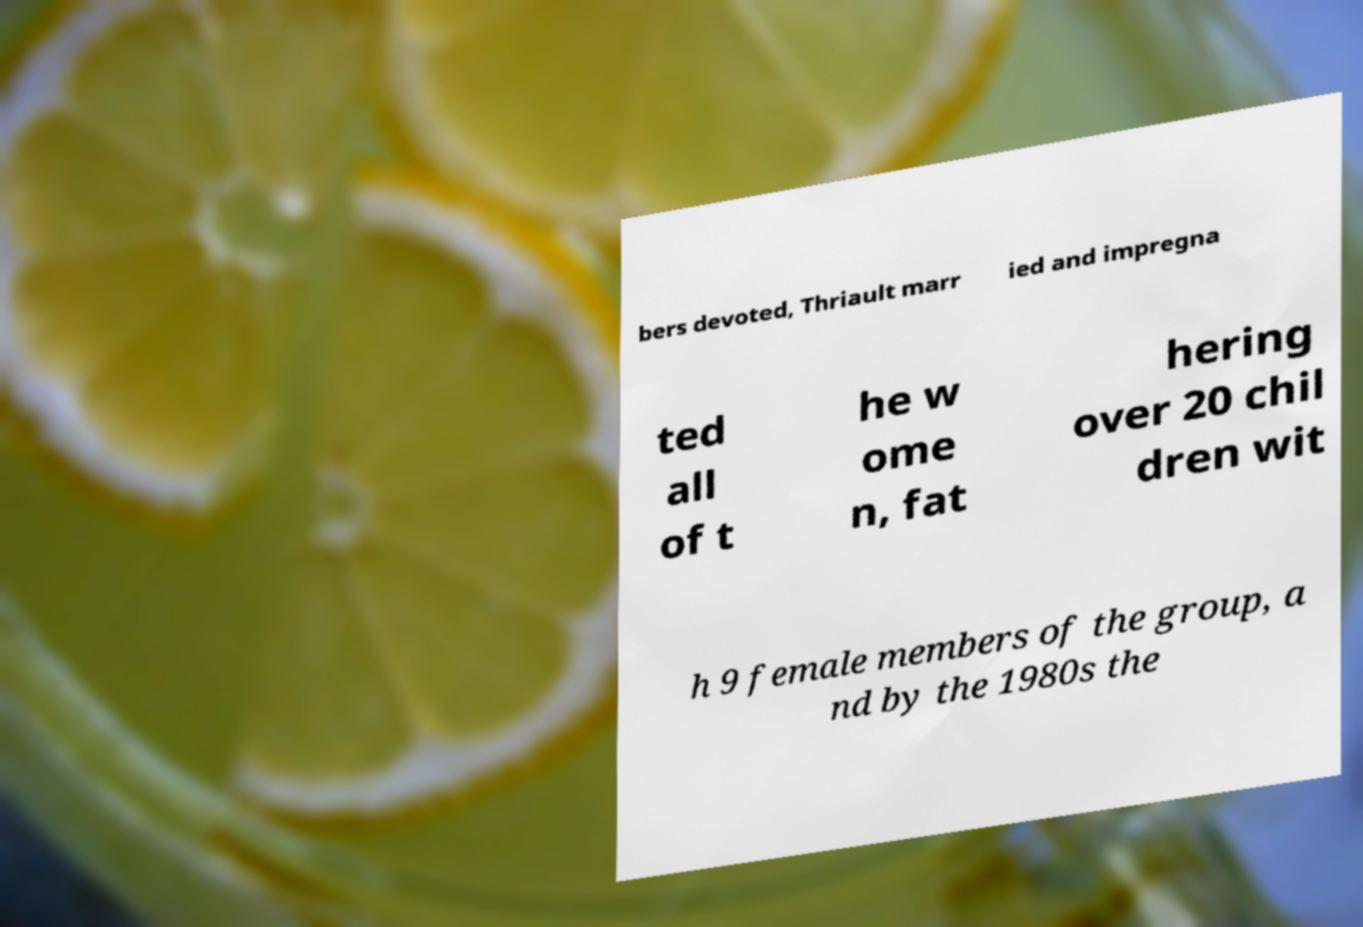For documentation purposes, I need the text within this image transcribed. Could you provide that? bers devoted, Thriault marr ied and impregna ted all of t he w ome n, fat hering over 20 chil dren wit h 9 female members of the group, a nd by the 1980s the 